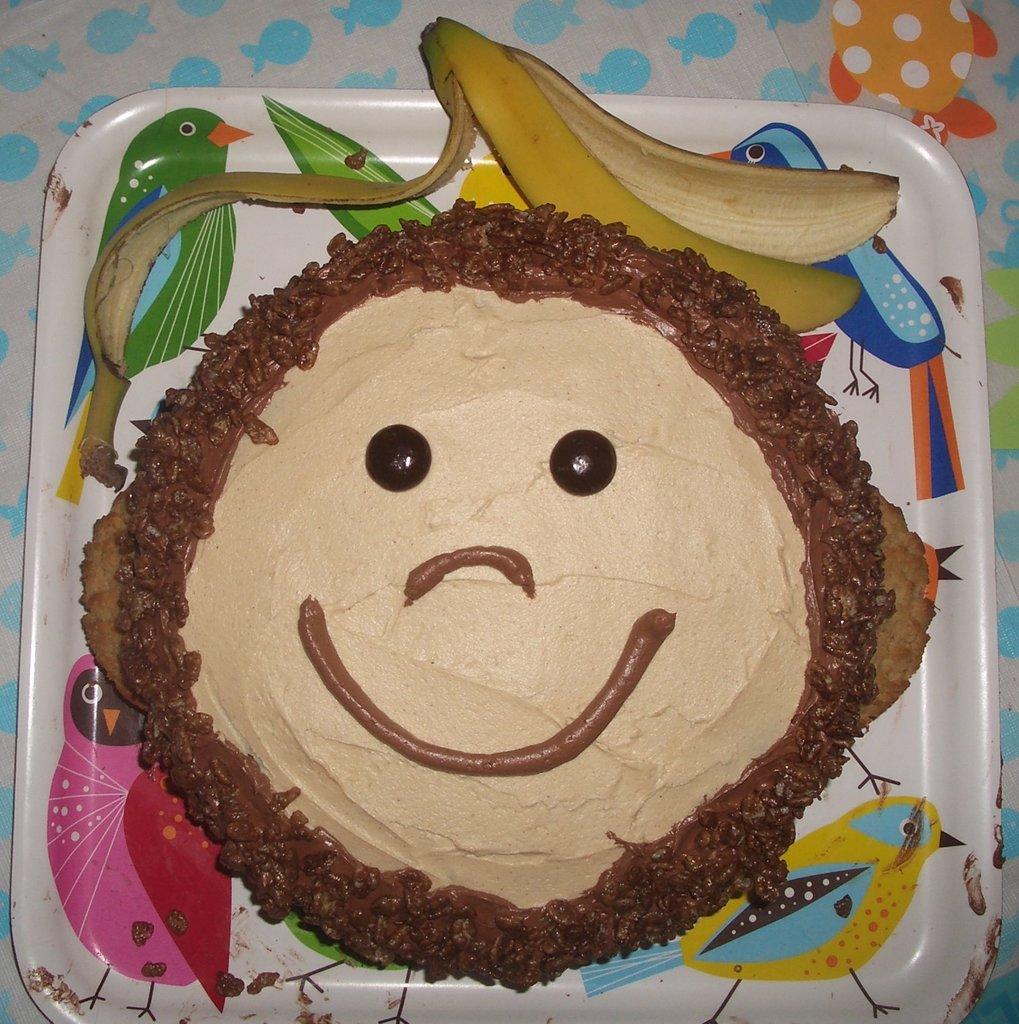Please provide a concise description of this image. In this image we can see a cake and a banana peel on the plate. In the background of the image there is a colorful background. 